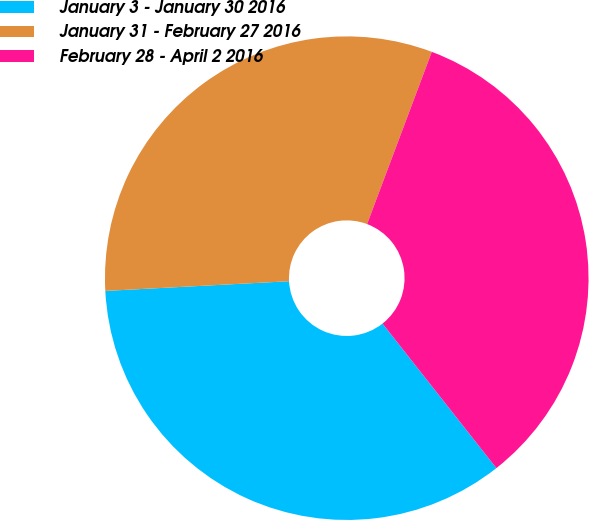<chart> <loc_0><loc_0><loc_500><loc_500><pie_chart><fcel>January 3 - January 30 2016<fcel>January 31 - February 27 2016<fcel>February 28 - April 2 2016<nl><fcel>34.78%<fcel>31.56%<fcel>33.66%<nl></chart> 